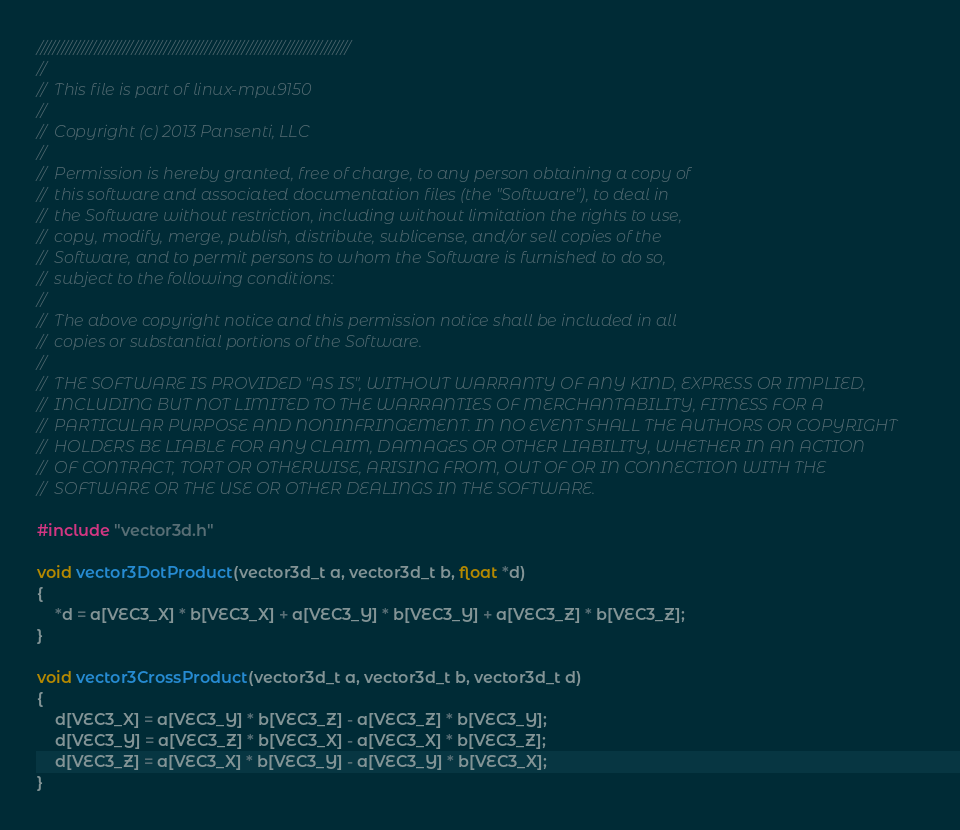Convert code to text. <code><loc_0><loc_0><loc_500><loc_500><_C_>////////////////////////////////////////////////////////////////////////////
//
//  This file is part of linux-mpu9150
//
//  Copyright (c) 2013 Pansenti, LLC
//
//  Permission is hereby granted, free of charge, to any person obtaining a copy of 
//  this software and associated documentation files (the "Software"), to deal in 
//  the Software without restriction, including without limitation the rights to use, 
//  copy, modify, merge, publish, distribute, sublicense, and/or sell copies of the 
//  Software, and to permit persons to whom the Software is furnished to do so, 
//  subject to the following conditions:
//
//  The above copyright notice and this permission notice shall be included in all 
//  copies or substantial portions of the Software.
//
//  THE SOFTWARE IS PROVIDED "AS IS", WITHOUT WARRANTY OF ANY KIND, EXPRESS OR IMPLIED, 
//  INCLUDING BUT NOT LIMITED TO THE WARRANTIES OF MERCHANTABILITY, FITNESS FOR A 
//  PARTICULAR PURPOSE AND NONINFRINGEMENT. IN NO EVENT SHALL THE AUTHORS OR COPYRIGHT 
//  HOLDERS BE LIABLE FOR ANY CLAIM, DAMAGES OR OTHER LIABILITY, WHETHER IN AN ACTION 
//  OF CONTRACT, TORT OR OTHERWISE, ARISING FROM, OUT OF OR IN CONNECTION WITH THE 
//  SOFTWARE OR THE USE OR OTHER DEALINGS IN THE SOFTWARE.

#include "vector3d.h"

void vector3DotProduct(vector3d_t a, vector3d_t b, float *d)
{
	*d = a[VEC3_X] * b[VEC3_X] + a[VEC3_Y] * b[VEC3_Y] + a[VEC3_Z] * b[VEC3_Z];  
}

void vector3CrossProduct(vector3d_t a, vector3d_t b, vector3d_t d) 
{
	d[VEC3_X] = a[VEC3_Y] * b[VEC3_Z] - a[VEC3_Z] * b[VEC3_Y];
	d[VEC3_Y] = a[VEC3_Z] * b[VEC3_X] - a[VEC3_X] * b[VEC3_Z];
	d[VEC3_Z] = a[VEC3_X] * b[VEC3_Y] - a[VEC3_Y] * b[VEC3_X];
}

</code> 